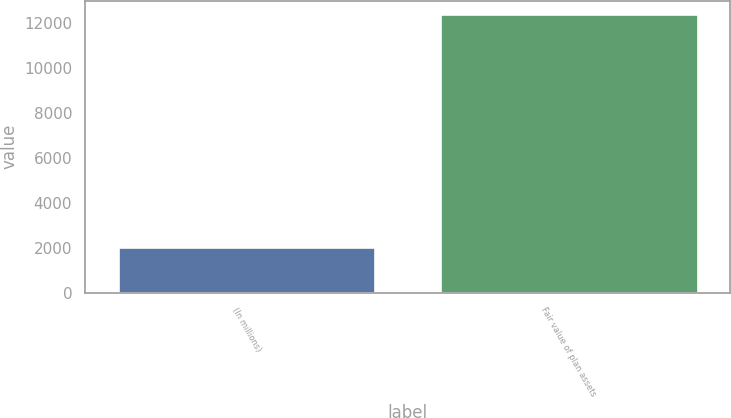<chart> <loc_0><loc_0><loc_500><loc_500><bar_chart><fcel>(In millions)<fcel>Fair value of plan assets<nl><fcel>2014<fcel>12386<nl></chart> 